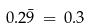Convert formula to latex. <formula><loc_0><loc_0><loc_500><loc_500>0 . 2 \bar { 9 } \, = \, 0 . 3</formula> 